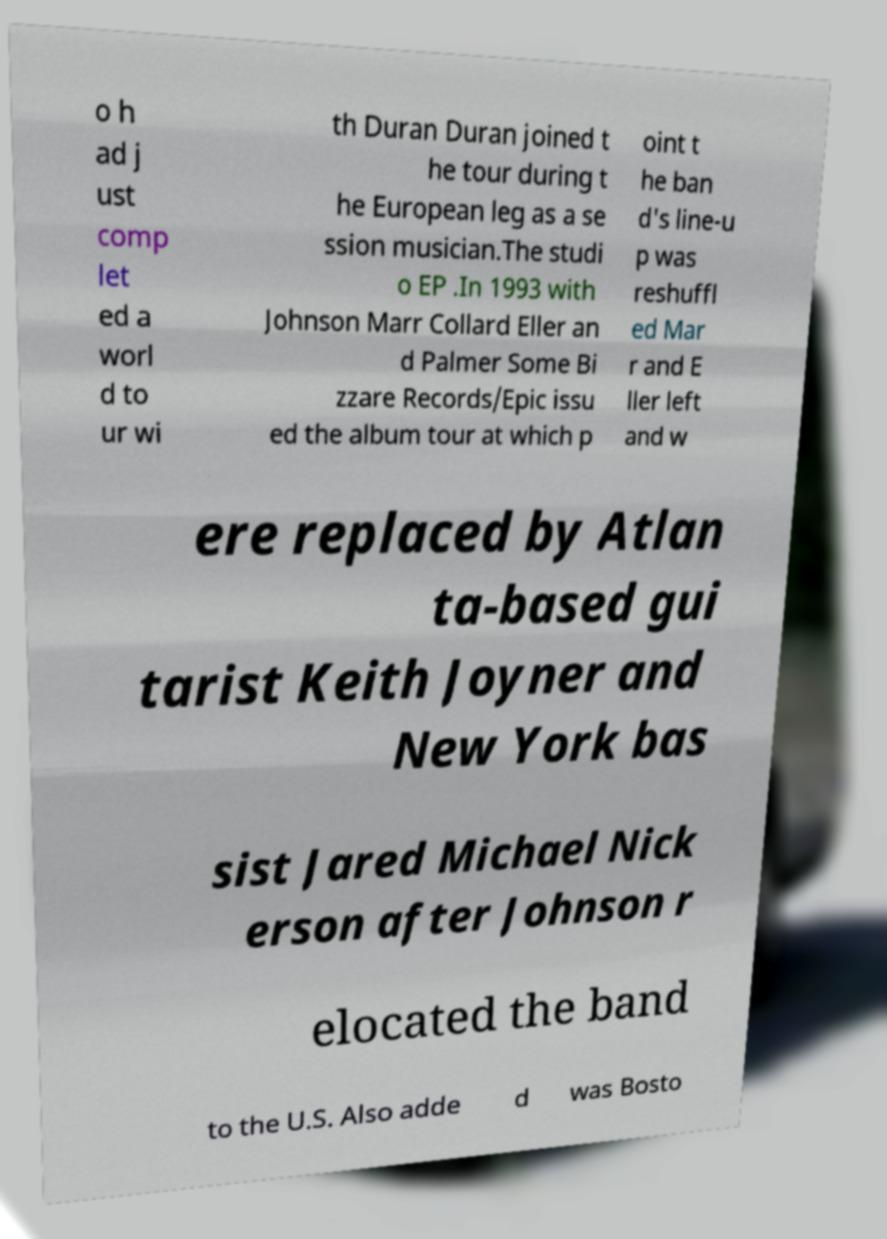There's text embedded in this image that I need extracted. Can you transcribe it verbatim? o h ad j ust comp let ed a worl d to ur wi th Duran Duran joined t he tour during t he European leg as a se ssion musician.The studi o EP .In 1993 with Johnson Marr Collard Eller an d Palmer Some Bi zzare Records/Epic issu ed the album tour at which p oint t he ban d's line-u p was reshuffl ed Mar r and E ller left and w ere replaced by Atlan ta-based gui tarist Keith Joyner and New York bas sist Jared Michael Nick erson after Johnson r elocated the band to the U.S. Also adde d was Bosto 